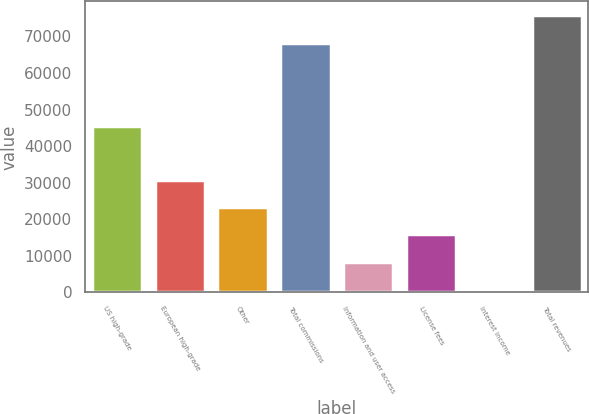Convert chart. <chart><loc_0><loc_0><loc_500><loc_500><bar_chart><fcel>US high-grade<fcel>European high-grade<fcel>Other<fcel>Total commissions<fcel>Information and user access<fcel>License fees<fcel>Interest income<fcel>Total revenues<nl><fcel>45465<fcel>30848<fcel>23356.5<fcel>68172<fcel>8373.5<fcel>15865<fcel>882<fcel>75797<nl></chart> 